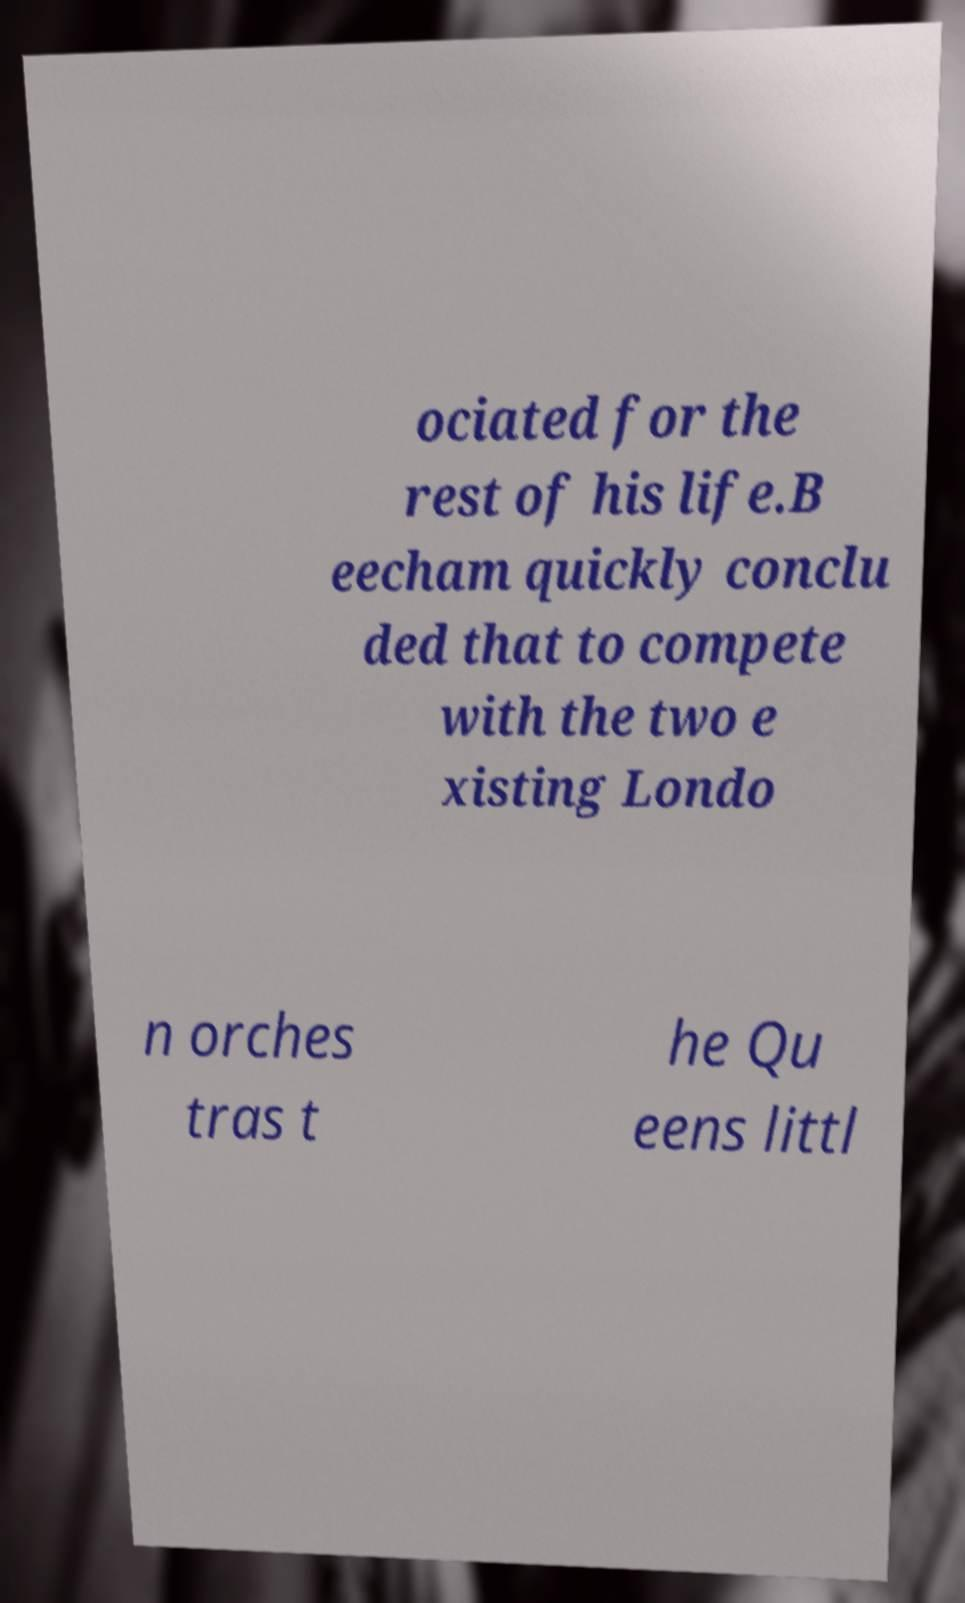Can you accurately transcribe the text from the provided image for me? ociated for the rest of his life.B eecham quickly conclu ded that to compete with the two e xisting Londo n orches tras t he Qu eens littl 